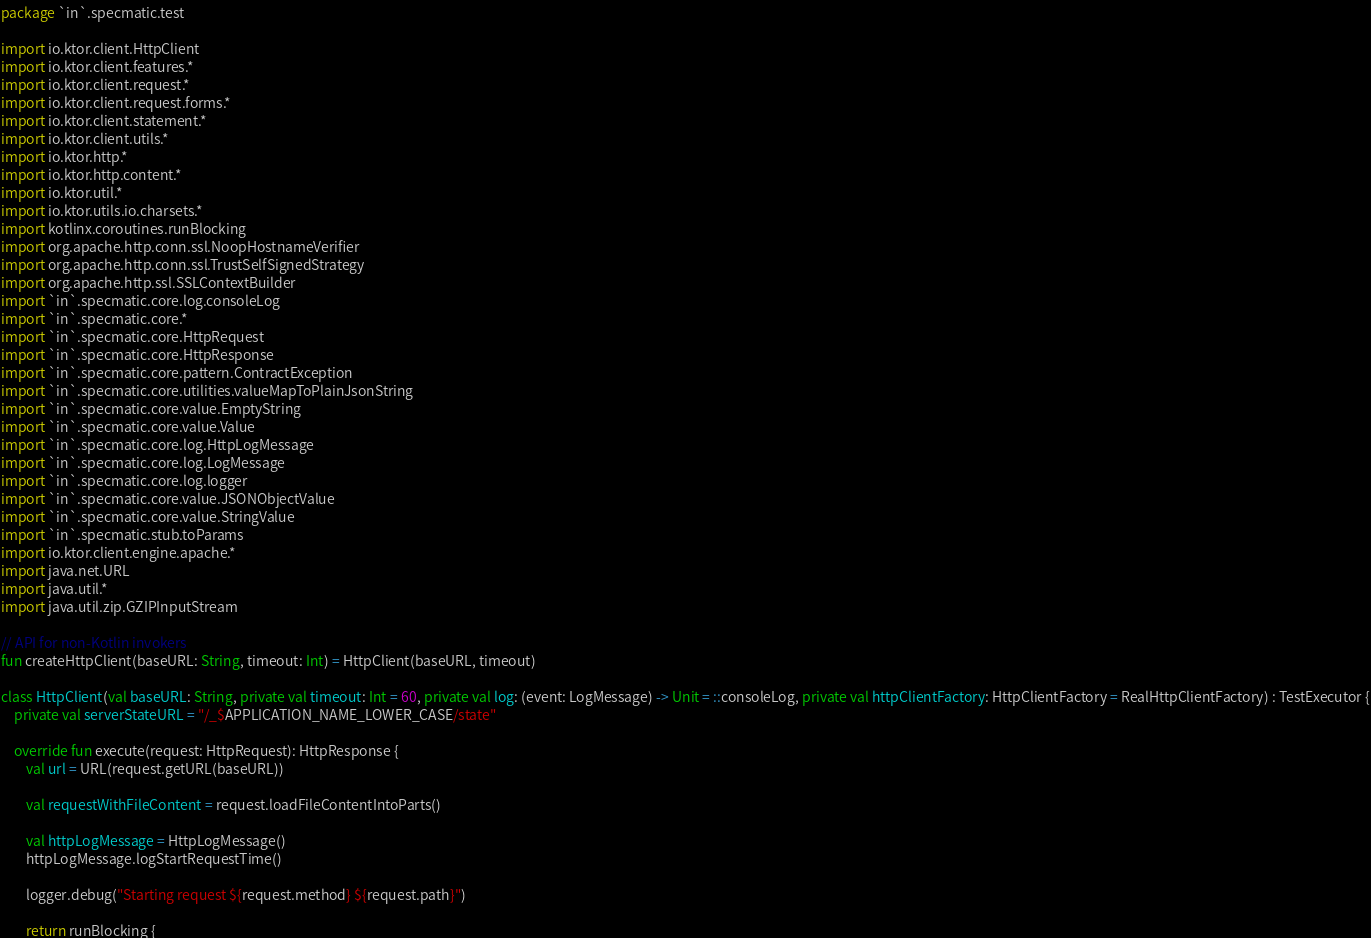Convert code to text. <code><loc_0><loc_0><loc_500><loc_500><_Kotlin_>package `in`.specmatic.test

import io.ktor.client.HttpClient
import io.ktor.client.features.*
import io.ktor.client.request.*
import io.ktor.client.request.forms.*
import io.ktor.client.statement.*
import io.ktor.client.utils.*
import io.ktor.http.*
import io.ktor.http.content.*
import io.ktor.util.*
import io.ktor.utils.io.charsets.*
import kotlinx.coroutines.runBlocking
import org.apache.http.conn.ssl.NoopHostnameVerifier
import org.apache.http.conn.ssl.TrustSelfSignedStrategy
import org.apache.http.ssl.SSLContextBuilder
import `in`.specmatic.core.log.consoleLog
import `in`.specmatic.core.*
import `in`.specmatic.core.HttpRequest
import `in`.specmatic.core.HttpResponse
import `in`.specmatic.core.pattern.ContractException
import `in`.specmatic.core.utilities.valueMapToPlainJsonString
import `in`.specmatic.core.value.EmptyString
import `in`.specmatic.core.value.Value
import `in`.specmatic.core.log.HttpLogMessage
import `in`.specmatic.core.log.LogMessage
import `in`.specmatic.core.log.logger
import `in`.specmatic.core.value.JSONObjectValue
import `in`.specmatic.core.value.StringValue
import `in`.specmatic.stub.toParams
import io.ktor.client.engine.apache.*
import java.net.URL
import java.util.*
import java.util.zip.GZIPInputStream

// API for non-Kotlin invokers
fun createHttpClient(baseURL: String, timeout: Int) = HttpClient(baseURL, timeout)

class HttpClient(val baseURL: String, private val timeout: Int = 60, private val log: (event: LogMessage) -> Unit = ::consoleLog, private val httpClientFactory: HttpClientFactory = RealHttpClientFactory) : TestExecutor {
    private val serverStateURL = "/_$APPLICATION_NAME_LOWER_CASE/state"

    override fun execute(request: HttpRequest): HttpResponse {
        val url = URL(request.getURL(baseURL))

        val requestWithFileContent = request.loadFileContentIntoParts()

        val httpLogMessage = HttpLogMessage()
        httpLogMessage.logStartRequestTime()

        logger.debug("Starting request ${request.method} ${request.path}")

        return runBlocking {</code> 